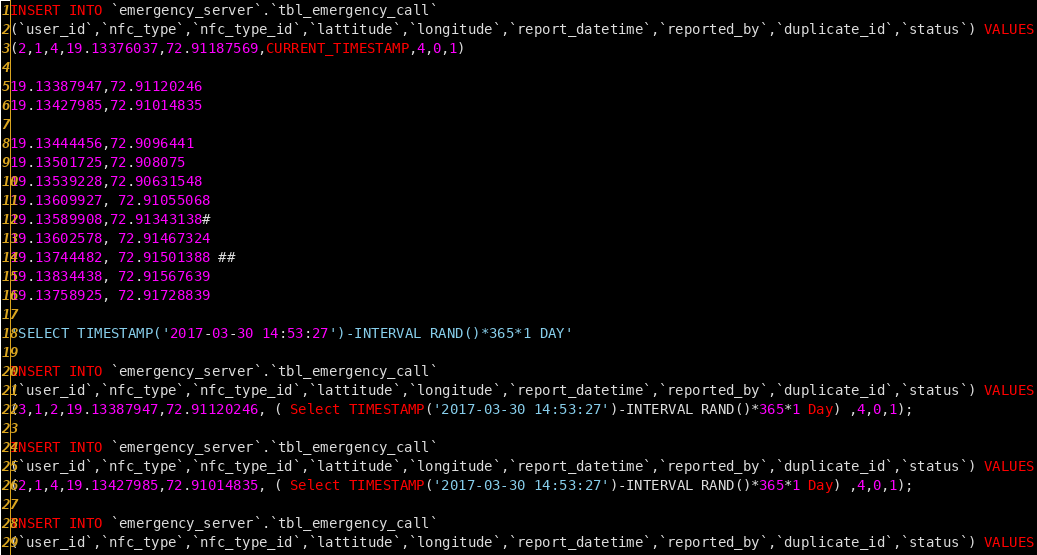<code> <loc_0><loc_0><loc_500><loc_500><_SQL_>INSERT INTO `emergency_server`.`tbl_emergency_call`
(`user_id`,`nfc_type`,`nfc_type_id`,`lattitude`,`longitude`,`report_datetime`,`reported_by`,`duplicate_id`,`status`) VALUES
(2,1,4,19.13376037,72.91187569,CURRENT_TIMESTAMP,4,0,1)

19.13387947,72.91120246
19.13427985,72.91014835

19.13444456,72.9096441
19.13501725,72.908075
19.13539228,72.90631548
19.13609927, 72.91055068
19.13589908,72.91343138#
19.13602578, 72.91467324
19.13744482, 72.91501388 ##
19.13834438, 72.91567639
19.13758925, 72.91728839

'SELECT TIMESTAMP('2017-03-30 14:53:27')-INTERVAL RAND()*365*1 DAY'

INSERT INTO `emergency_server`.`tbl_emergency_call`
(`user_id`,`nfc_type`,`nfc_type_id`,`lattitude`,`longitude`,`report_datetime`,`reported_by`,`duplicate_id`,`status`) VALUES
(3,1,2,19.13387947,72.91120246, ( Select TIMESTAMP('2017-03-30 14:53:27')-INTERVAL RAND()*365*1 Day) ,4,0,1);

INSERT INTO `emergency_server`.`tbl_emergency_call`
(`user_id`,`nfc_type`,`nfc_type_id`,`lattitude`,`longitude`,`report_datetime`,`reported_by`,`duplicate_id`,`status`) VALUES
(2,1,4,19.13427985,72.91014835, ( Select TIMESTAMP('2017-03-30 14:53:27')-INTERVAL RAND()*365*1 Day) ,4,0,1);

INSERT INTO `emergency_server`.`tbl_emergency_call`
(`user_id`,`nfc_type`,`nfc_type_id`,`lattitude`,`longitude`,`report_datetime`,`reported_by`,`duplicate_id`,`status`) VALUES</code> 